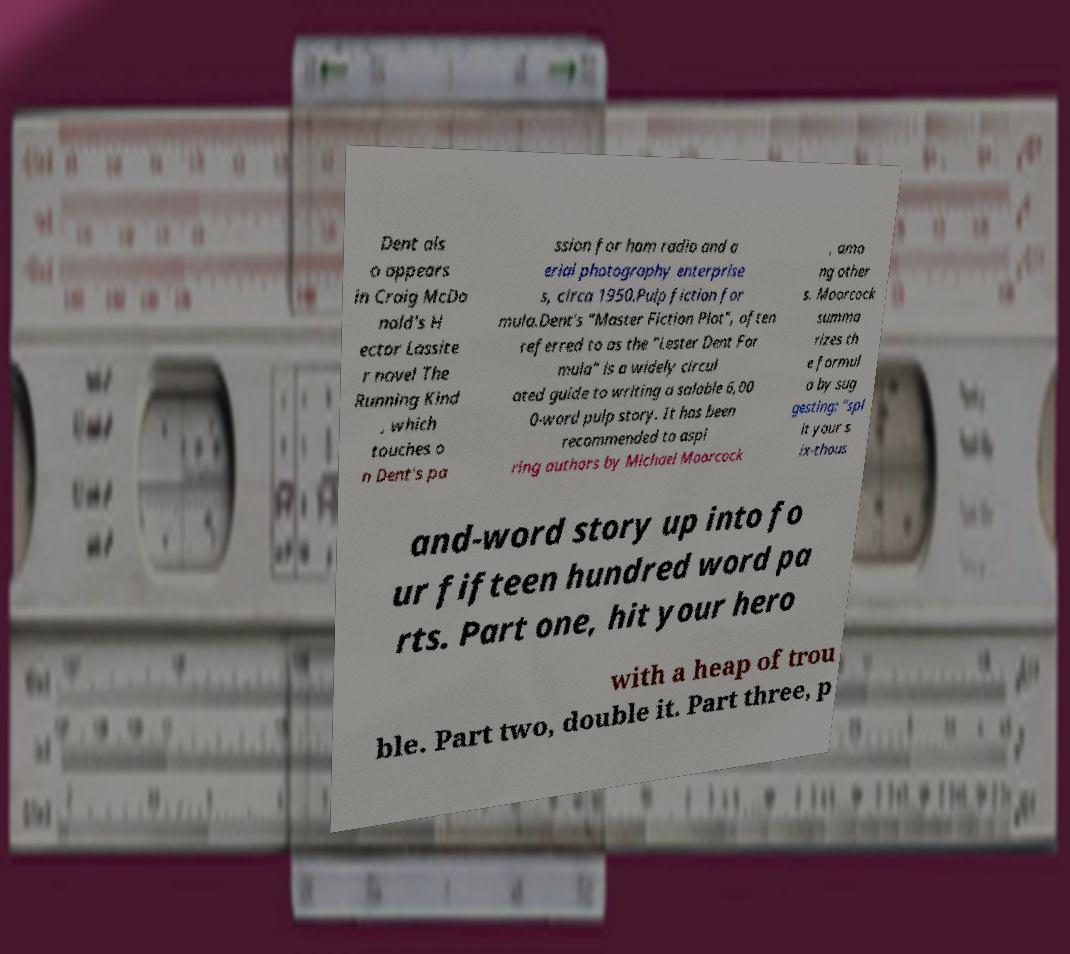Can you accurately transcribe the text from the provided image for me? Dent als o appears in Craig McDo nald's H ector Lassite r novel The Running Kind , which touches o n Dent's pa ssion for ham radio and a erial photography enterprise s, circa 1950.Pulp fiction for mula.Dent's "Master Fiction Plot", often referred to as the "Lester Dent For mula" is a widely circul ated guide to writing a salable 6,00 0-word pulp story. It has been recommended to aspi ring authors by Michael Moorcock , amo ng other s. Moorcock summa rizes th e formul a by sug gesting: "spl it your s ix-thous and-word story up into fo ur fifteen hundred word pa rts. Part one, hit your hero with a heap of trou ble. Part two, double it. Part three, p 